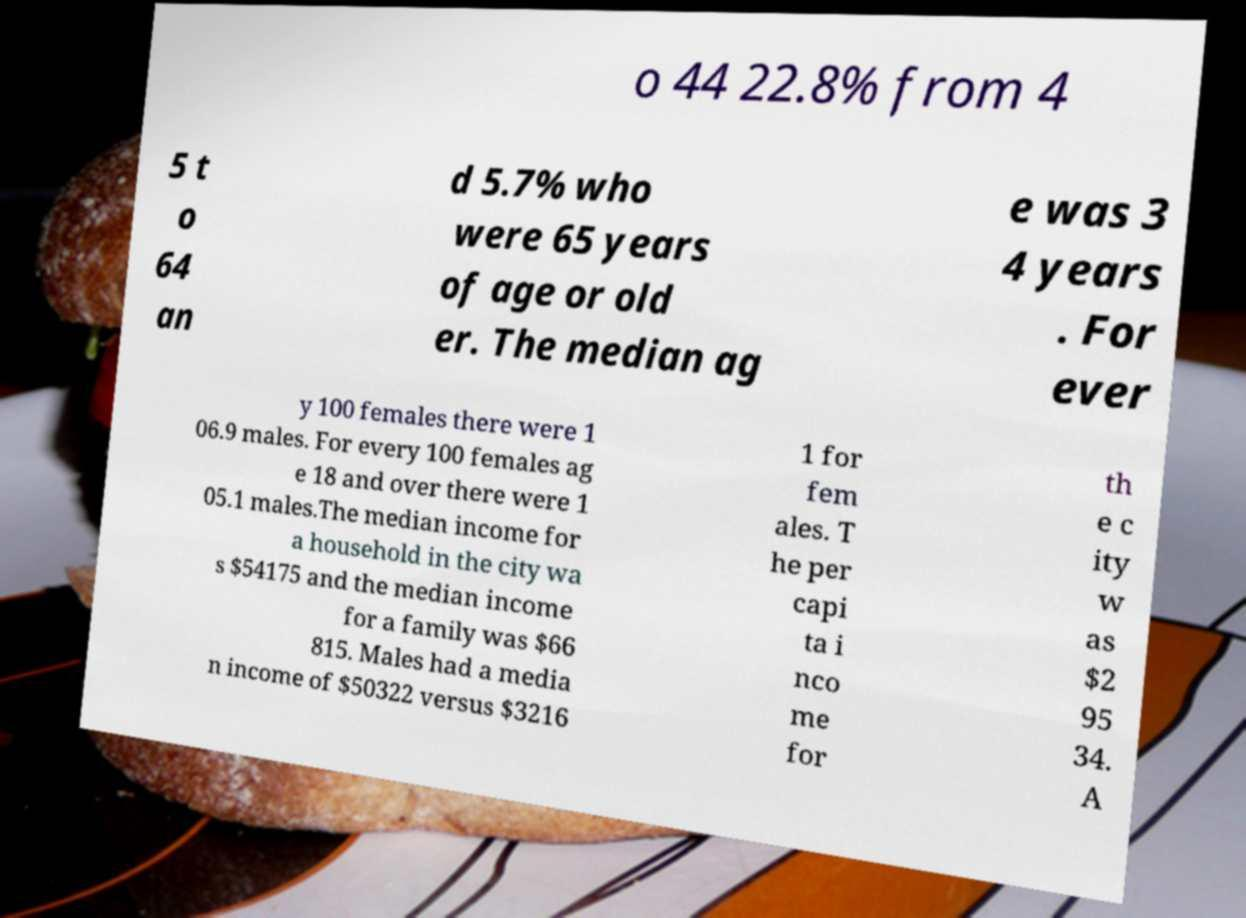For documentation purposes, I need the text within this image transcribed. Could you provide that? o 44 22.8% from 4 5 t o 64 an d 5.7% who were 65 years of age or old er. The median ag e was 3 4 years . For ever y 100 females there were 1 06.9 males. For every 100 females ag e 18 and over there were 1 05.1 males.The median income for a household in the city wa s $54175 and the median income for a family was $66 815. Males had a media n income of $50322 versus $3216 1 for fem ales. T he per capi ta i nco me for th e c ity w as $2 95 34. A 